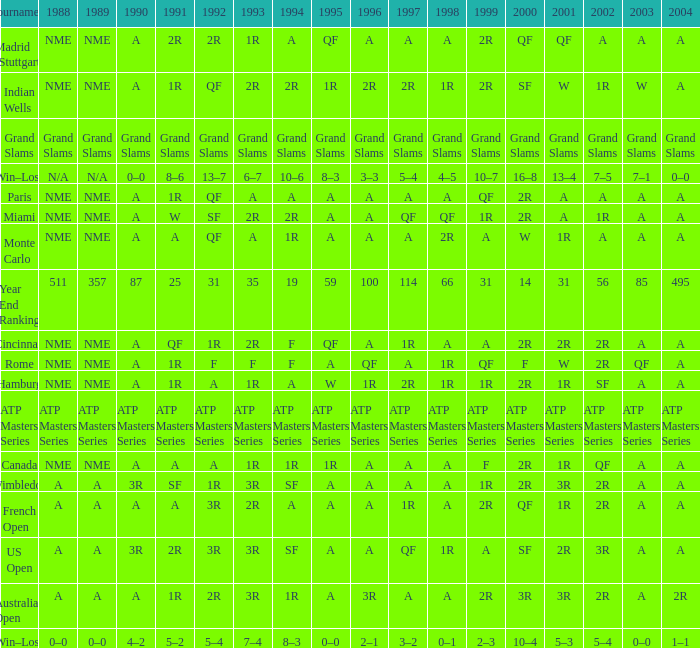What shows for 1988 when 1994 shows 10–6? N/A. 